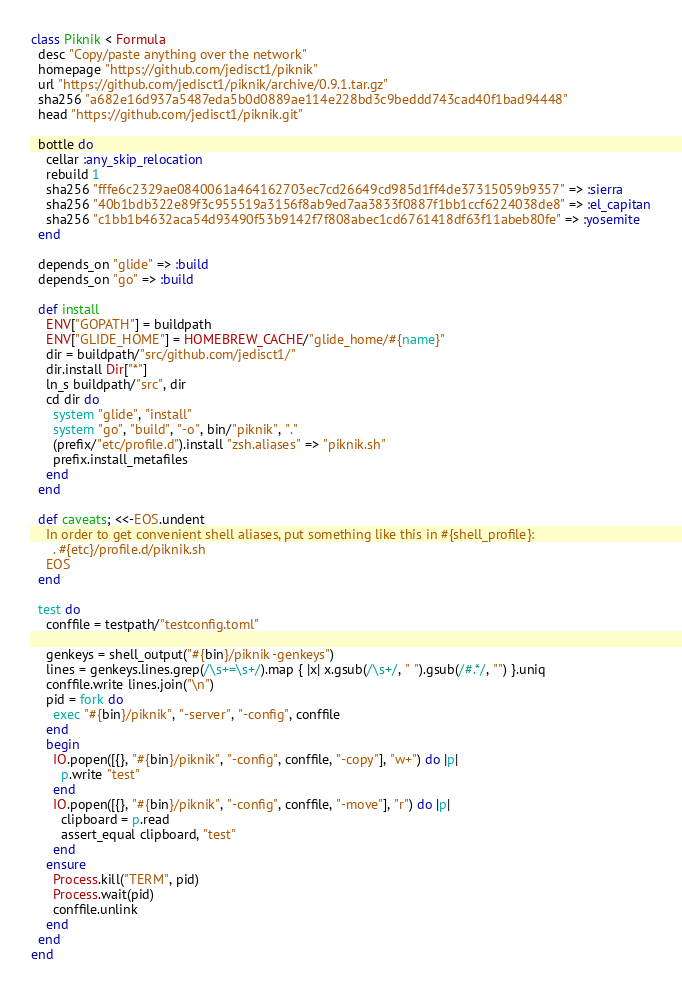Convert code to text. <code><loc_0><loc_0><loc_500><loc_500><_Ruby_>class Piknik < Formula
  desc "Copy/paste anything over the network"
  homepage "https://github.com/jedisct1/piknik"
  url "https://github.com/jedisct1/piknik/archive/0.9.1.tar.gz"
  sha256 "a682e16d937a5487eda5b0d0889ae114e228bd3c9beddd743cad40f1bad94448"
  head "https://github.com/jedisct1/piknik.git"

  bottle do
    cellar :any_skip_relocation
    rebuild 1
    sha256 "fffe6c2329ae0840061a464162703ec7cd26649cd985d1ff4de37315059b9357" => :sierra
    sha256 "40b1bdb322e89f3c955519a3156f8ab9ed7aa3833f0887f1bb1ccf6224038de8" => :el_capitan
    sha256 "c1bb1b4632aca54d93490f53b9142f7f808abec1cd6761418df63f11abeb80fe" => :yosemite
  end

  depends_on "glide" => :build
  depends_on "go" => :build

  def install
    ENV["GOPATH"] = buildpath
    ENV["GLIDE_HOME"] = HOMEBREW_CACHE/"glide_home/#{name}"
    dir = buildpath/"src/github.com/jedisct1/"
    dir.install Dir["*"]
    ln_s buildpath/"src", dir
    cd dir do
      system "glide", "install"
      system "go", "build", "-o", bin/"piknik", "."
      (prefix/"etc/profile.d").install "zsh.aliases" => "piknik.sh"
      prefix.install_metafiles
    end
  end

  def caveats; <<-EOS.undent
    In order to get convenient shell aliases, put something like this in #{shell_profile}:
      . #{etc}/profile.d/piknik.sh
    EOS
  end

  test do
    conffile = testpath/"testconfig.toml"

    genkeys = shell_output("#{bin}/piknik -genkeys")
    lines = genkeys.lines.grep(/\s+=\s+/).map { |x| x.gsub(/\s+/, " ").gsub(/#.*/, "") }.uniq
    conffile.write lines.join("\n")
    pid = fork do
      exec "#{bin}/piknik", "-server", "-config", conffile
    end
    begin
      IO.popen([{}, "#{bin}/piknik", "-config", conffile, "-copy"], "w+") do |p|
        p.write "test"
      end
      IO.popen([{}, "#{bin}/piknik", "-config", conffile, "-move"], "r") do |p|
        clipboard = p.read
        assert_equal clipboard, "test"
      end
    ensure
      Process.kill("TERM", pid)
      Process.wait(pid)
      conffile.unlink
    end
  end
end
</code> 